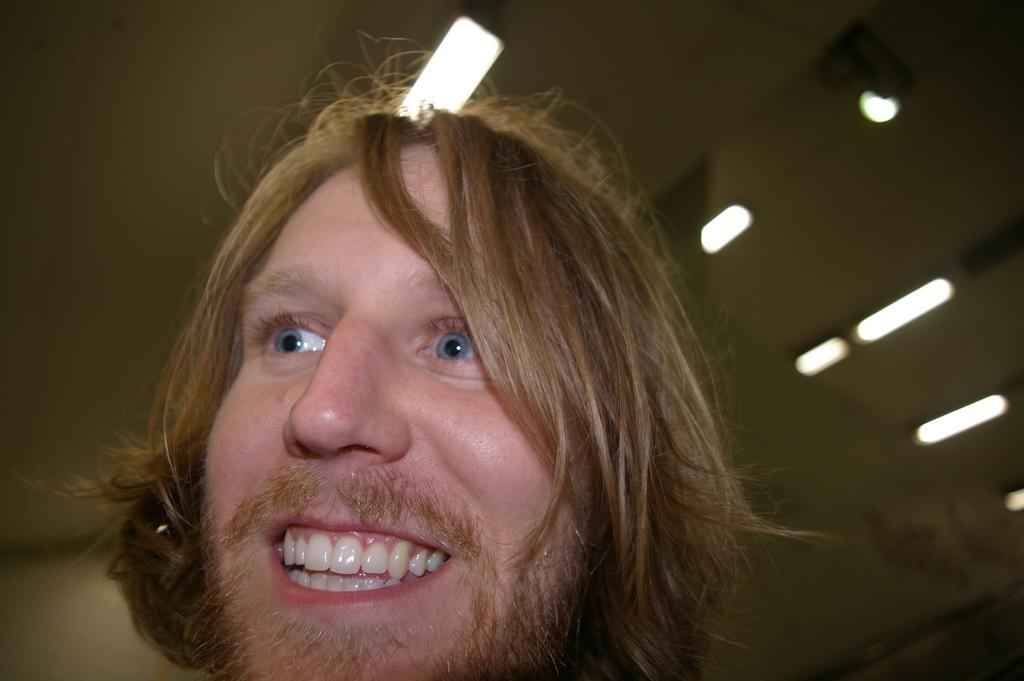What is the main subject in the foreground of the image? There is a person in the foreground of the image. What can be seen at the top of the image? There is a ceiling with lights visible at the top of the image. How does the girl use the gun in the image? There is no girl or gun present in the image. 